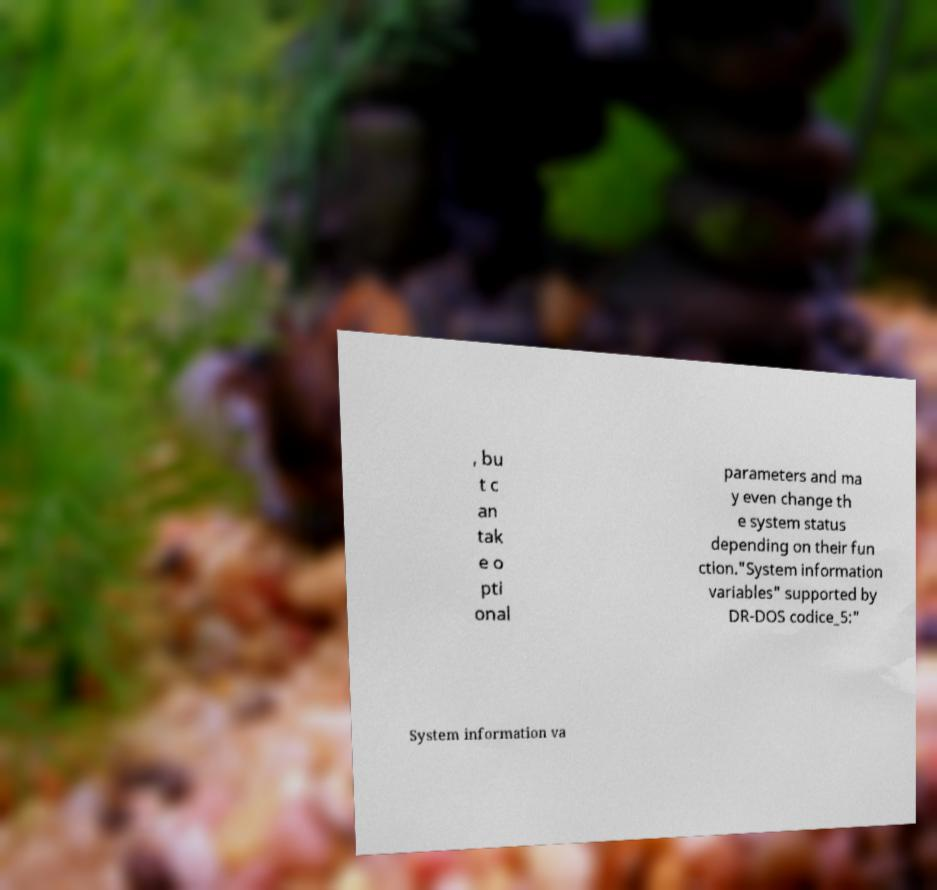Please identify and transcribe the text found in this image. , bu t c an tak e o pti onal parameters and ma y even change th e system status depending on their fun ction."System information variables" supported by DR-DOS codice_5:" System information va 